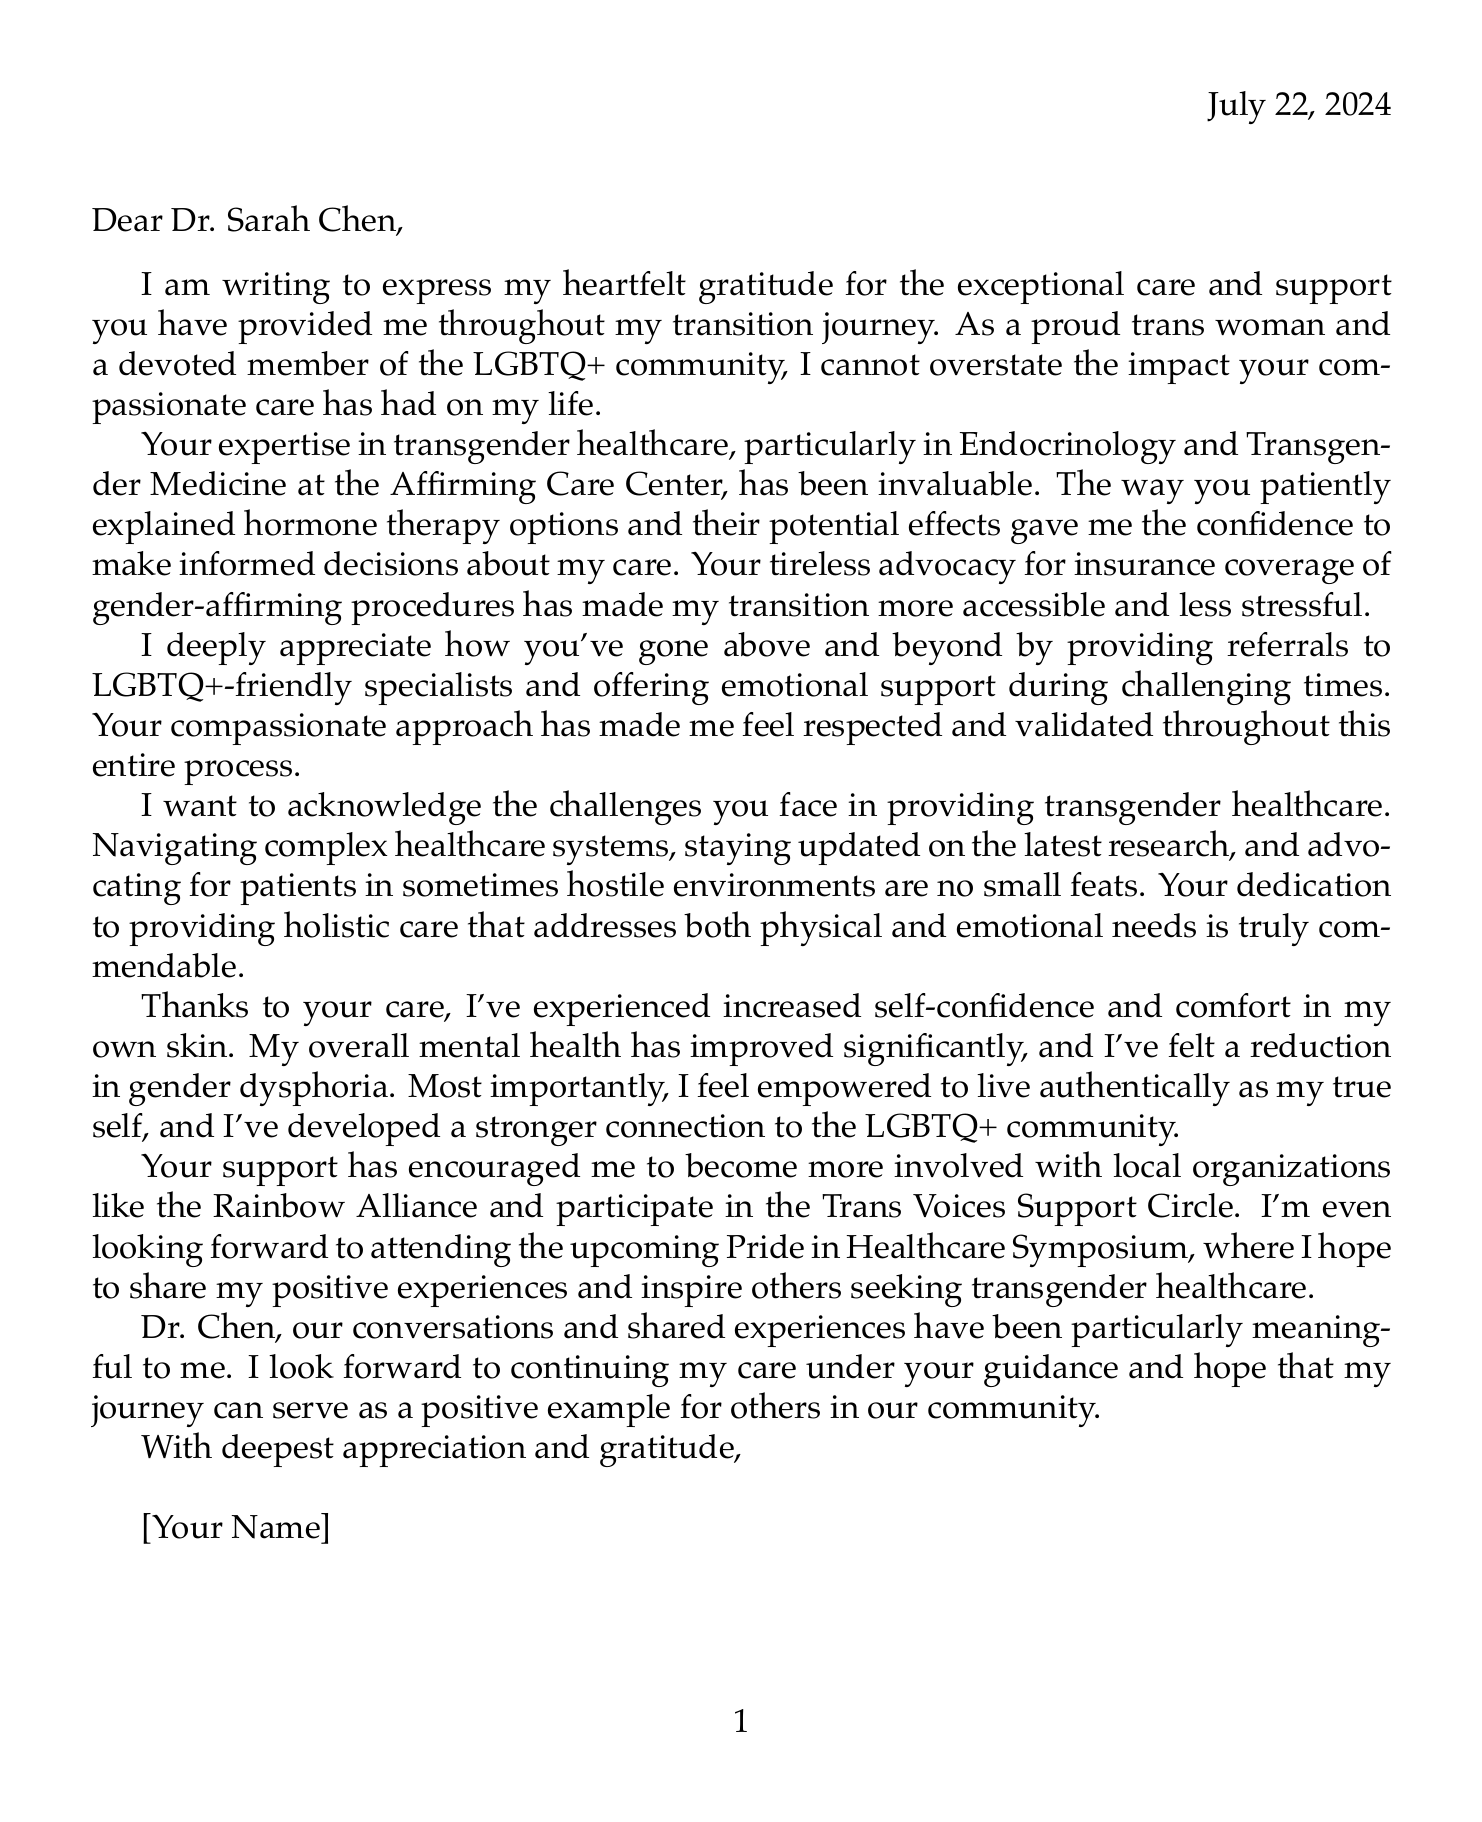What is the provider's name? The provider's name is mentioned at the beginning of the letter as the recipient.
Answer: Dr. Sarah Chen What is the name of the clinic? The clinic is identified as the place where the provider works and offers the services.
Answer: Affirming Care Center What is the specialization of Dr. Chen? Dr. Chen's area of expertise is explicitly mentioned in the document.
Answer: Endocrinology and Transgender Medicine What kind of support group is mentioned? The letter references a specific supportive community related to transgender individuals.
Answer: Trans Voices Support Circle What are the key positive impacts mentioned in the letter? The letter discusses the effects of the provider's care on the author's life, mentioning multiple aspects.
Answer: Increased self-confidence and comfort in my own skin What challenges does Dr. Chen face in providing care? The author acknowledges certain difficulties encountered by the provider in their practice.
Answer: Navigating complex healthcare systems What does the author wish to do at the upcoming event? The author expresses an intention to participate in a community event and share experiences.
Answer: Share positive experiences What is the date of the letter? The date is included in the letter as part of its formatting.
Answer: Today's date What kind of therapy options were explained to the author? Specific treatments are noted in the gratitude expressed in the letter.
Answer: Hormone therapy options 